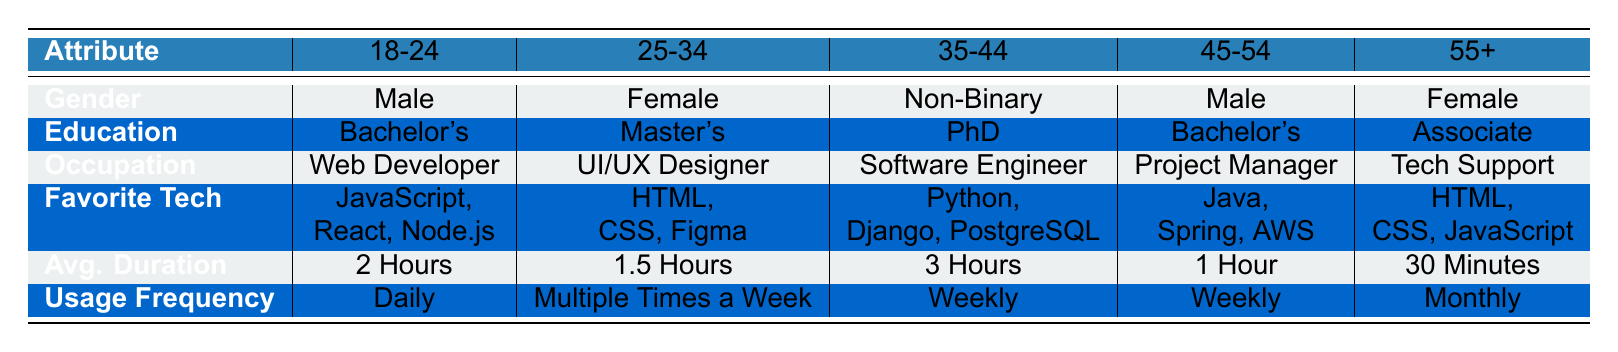What is the average duration on apps for the age group 25-34? From the table, the average duration on apps for the age group 25-34 is listed as 1.5 Hours.
Answer: 1.5 Hours Which age group has the highest average duration on apps? By reviewing the average durations in the table: 2 Hours for 18-24, 1.5 Hours for 25-34, 3 Hours for 35-44, 1 Hour for 45-54, and 30 Minutes for 55+. The highest is 3 Hours for the 35-44 age group.
Answer: 35-44 Is it true that all respondents have a Bachelor's degree or higher? Examining the education levels: The age groups 18-24 and 45-54 both have a Bachelor's degree, 25-34 has a Master's degree, 35-44 has a PhD, and 55+ has an Associate degree. Since 55+ has an Associate degree which is lower than a Bachelor's, the statement is false.
Answer: No Which gender is most commonly associated with the 55+ age group? Checking the gender for the 55+ age group in the table, it states Female.
Answer: Female What is the difference in average duration on apps between the 18-24 and 45-54 age groups? The average duration for 18-24 is 2 Hours, and for 45-54 is 1 Hour. To find the difference, convert 2 Hours to minutes (120 minutes) and 1 Hour to minutes (60 minutes), then subtract: 120 - 60 = 60 minutes. Hence, the difference is 1 Hour.
Answer: 1 Hour Do both male respondents have the same favorite tech stack? The favorite tech stacks for both Male respondents are different: 18-24 enjoys JavaScript, React, and Node.js while 45-54 uses Java, Spring, and AWS. Therefore, they do not have the same favorite tech stack.
Answer: No What is the average age group of users who have a daily usage frequency? From the table, only the age group 18-24 reports a daily usage frequency. Hence, the average age for users with daily usage is just that group, which is 18-24.
Answer: 18-24 How many users primarily work in technical roles (Web Developer, Software Engineer, Project Manager)? The users in technical roles are 18-24 (Web Developer), 35-44 (Software Engineer), and 45-54 (Project Manager) totaling three users in these occupations.
Answer: 3 